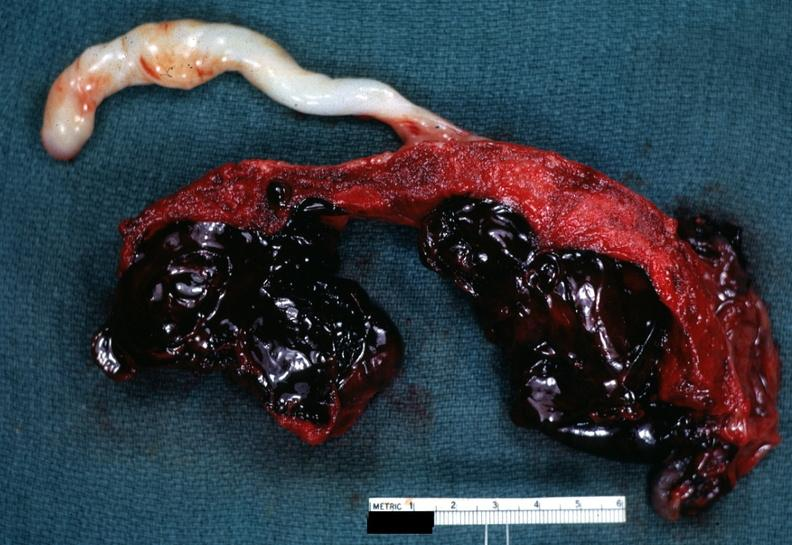what does this image show?
Answer the question using a single word or phrase. Saggital section which is a very good illustration of lesion 